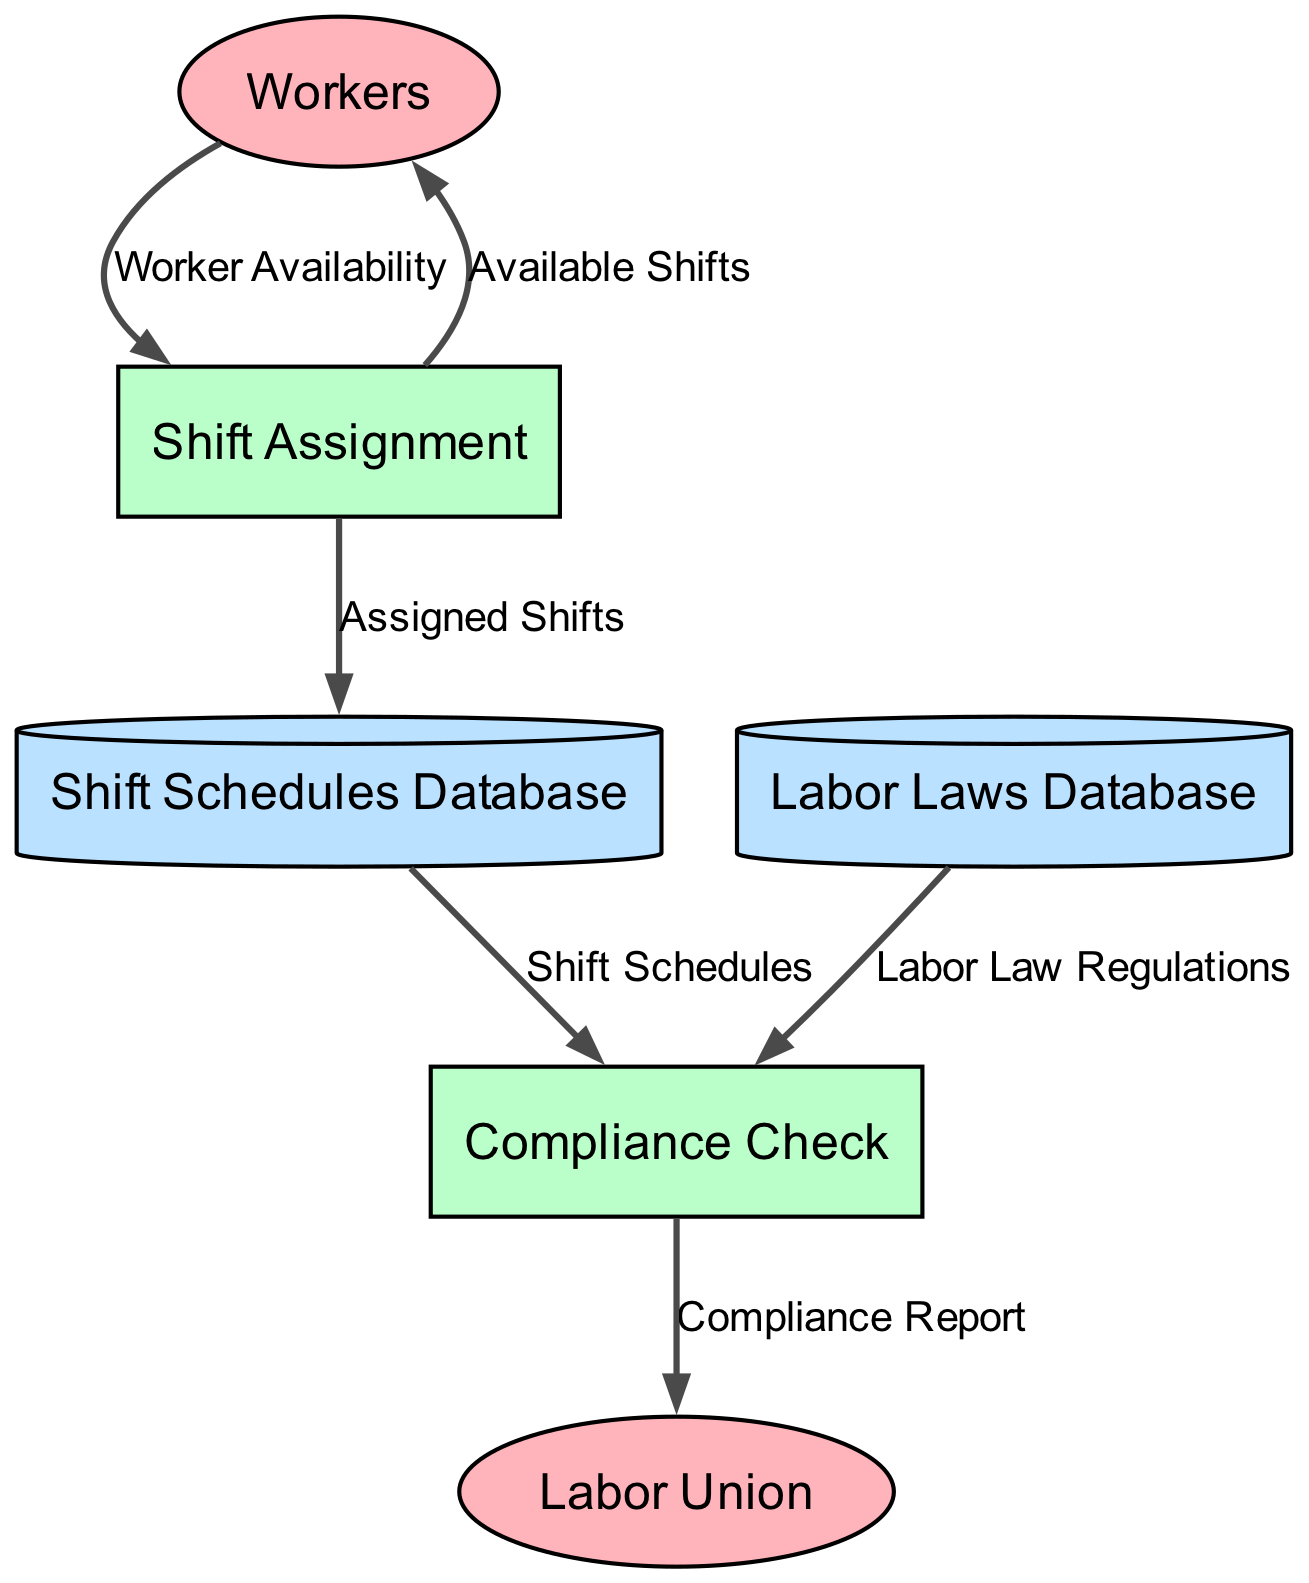What is the name of the data store that stores information about assigned shifts? The data store responsible for storing information about assigned shifts is labeled as "Shift Schedules Database".
Answer: Shift Schedules Database Which process checks the compliance of shift schedules with labor laws? The process that checks compliance with labor laws is called "Compliance Check".
Answer: Compliance Check How many external entities are present in the diagram? In the diagram, there are two external entities: "Workers" and "Labor Union". Counting them gives a total of 2 external entities.
Answer: 2 What type of information is sent from Workers to Shift Assignment? The information sent from Workers to Shift Assignment is labeled as "Worker Availability", indicating which workers are available for shifts.
Answer: Worker Availability What does the Compliance Report indicate? The Compliance Report indicates the compliance status of the shift schedules, providing crucial information about whether the schedules adhere to labor laws.
Answer: Compliance status What is the flow of data from Compliance Check to Labor Union? The flow of data from Compliance Check to Labor Union is named "Compliance Report", which contains reports about the compliance of shift schedules.
Answer: Compliance Report What color represents the processes in the diagram? The processes in the diagram are represented with a green color fill, indicated in the diagram's styling.
Answer: Green Which database provides the labor law regulations to the Compliance Check? The database that provides the relevant labor law regulations to the Compliance Check is named "Labor Laws Database".
Answer: Labor Laws Database What is the output of the "Shift Assignment" process to the "Shift Schedules Database"? The output from the "Shift Assignment" process to the "Shift Schedules Database" is labeled as "Assigned Shifts", which contains information about worker assignments.
Answer: Assigned Shifts 